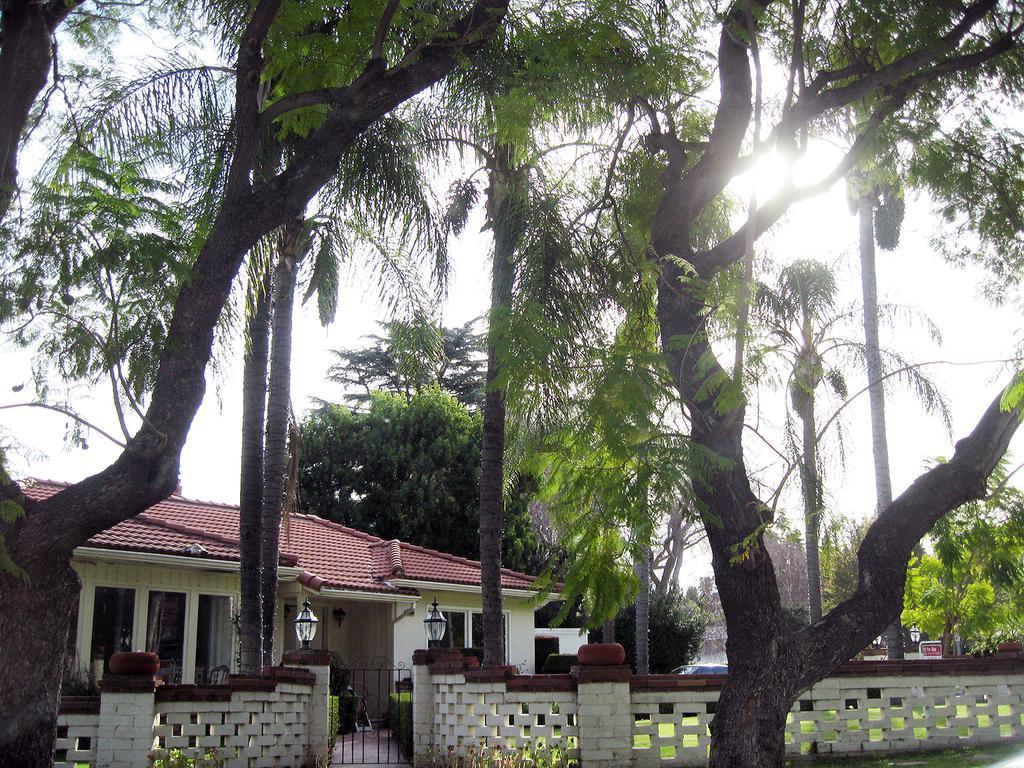In one or two sentences, can you explain what this image depicts? On the left side of the image we can see a house. At the bottom of the image we can see a fencing, lamp, ground, board are there. In the background of the image trees are there. At the top of the image sky is present. 